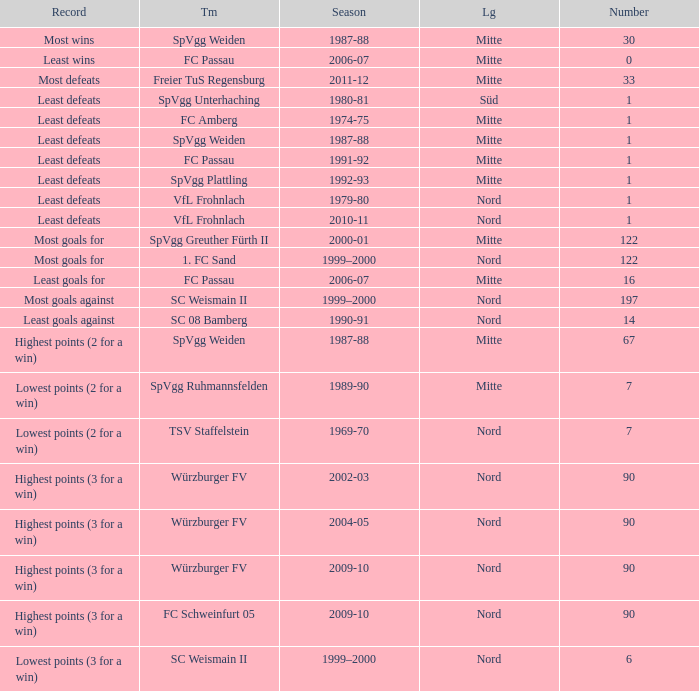What league has most wins as the record? Mitte. 